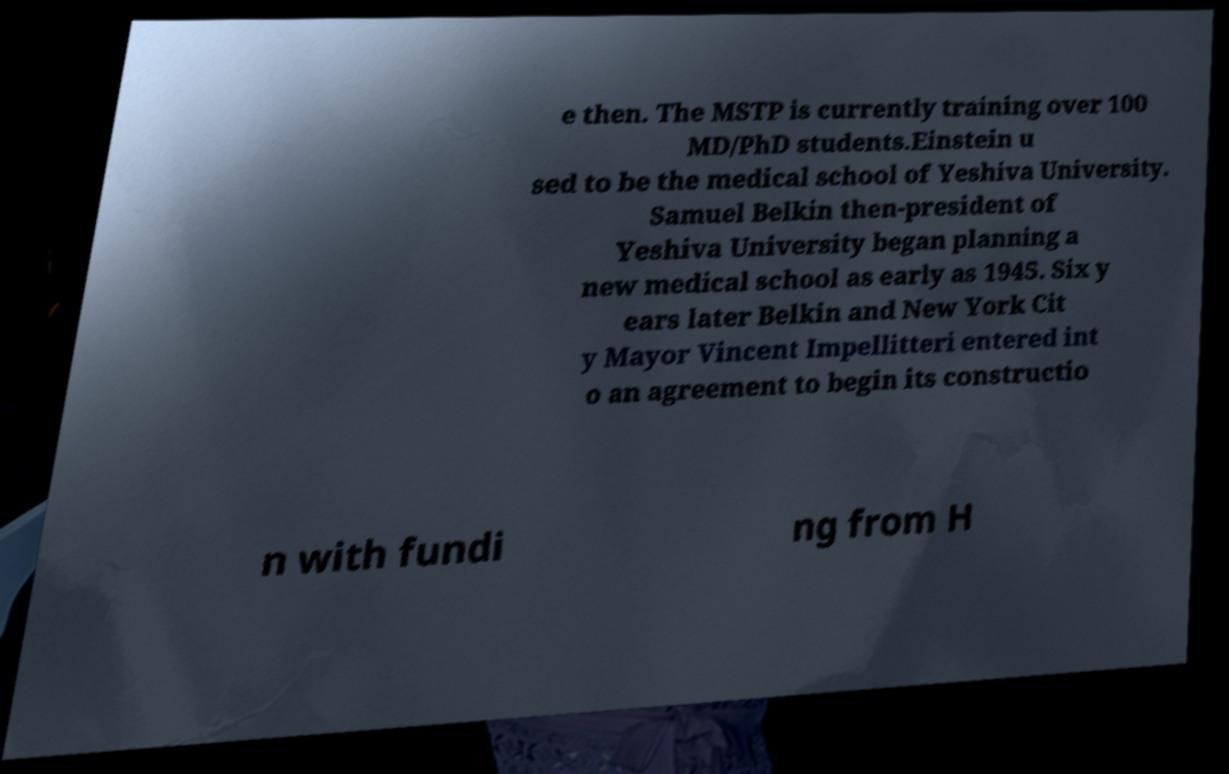What messages or text are displayed in this image? I need them in a readable, typed format. e then. The MSTP is currently training over 100 MD/PhD students.Einstein u sed to be the medical school of Yeshiva University. Samuel Belkin then-president of Yeshiva University began planning a new medical school as early as 1945. Six y ears later Belkin and New York Cit y Mayor Vincent Impellitteri entered int o an agreement to begin its constructio n with fundi ng from H 